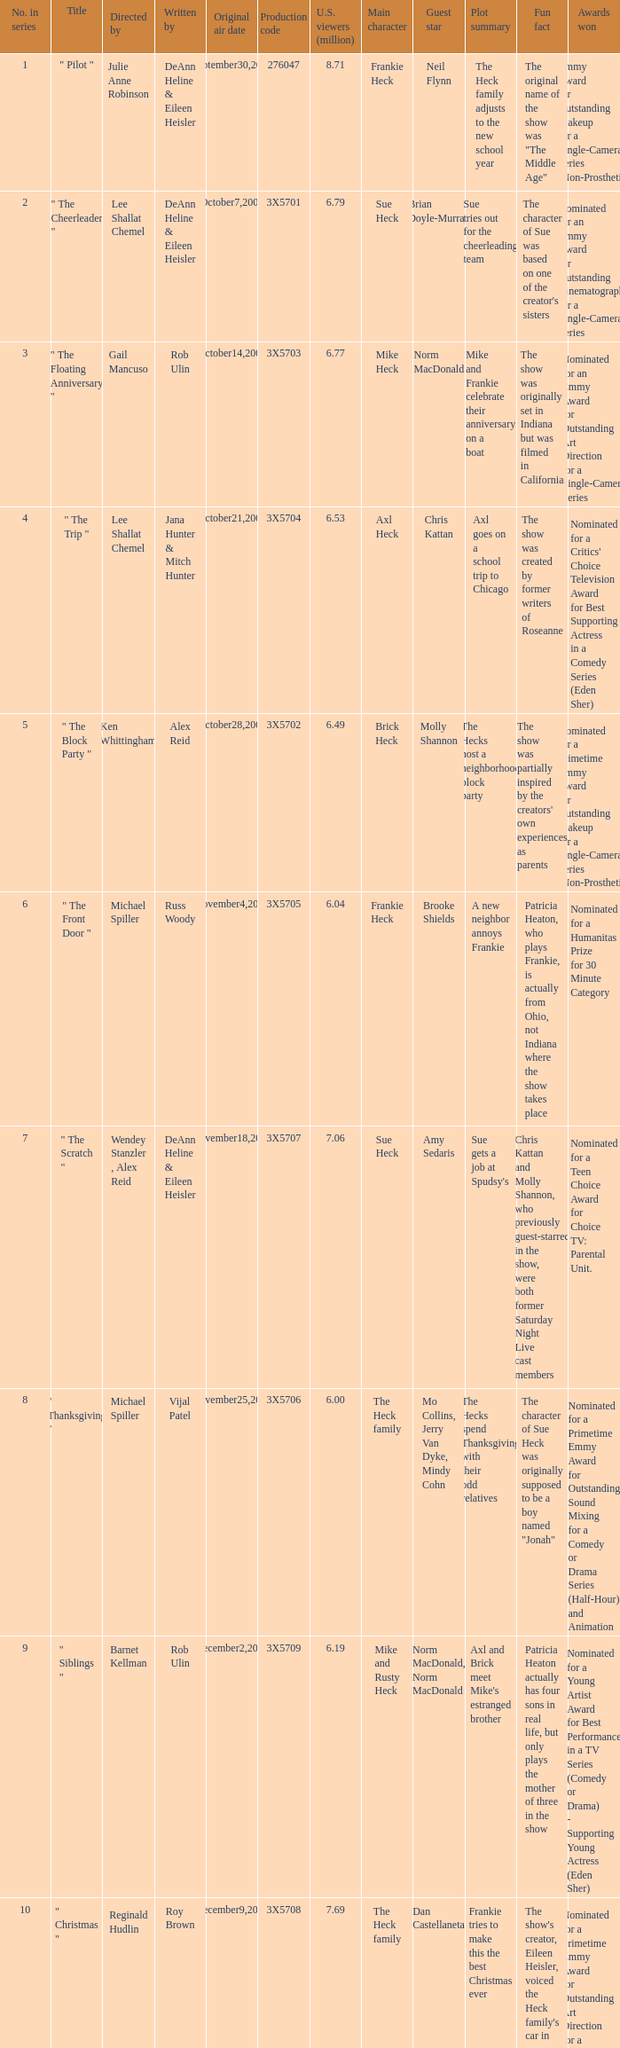Who wrote the episode that got 5.95 million U.S. viewers? Vijal Patel. 